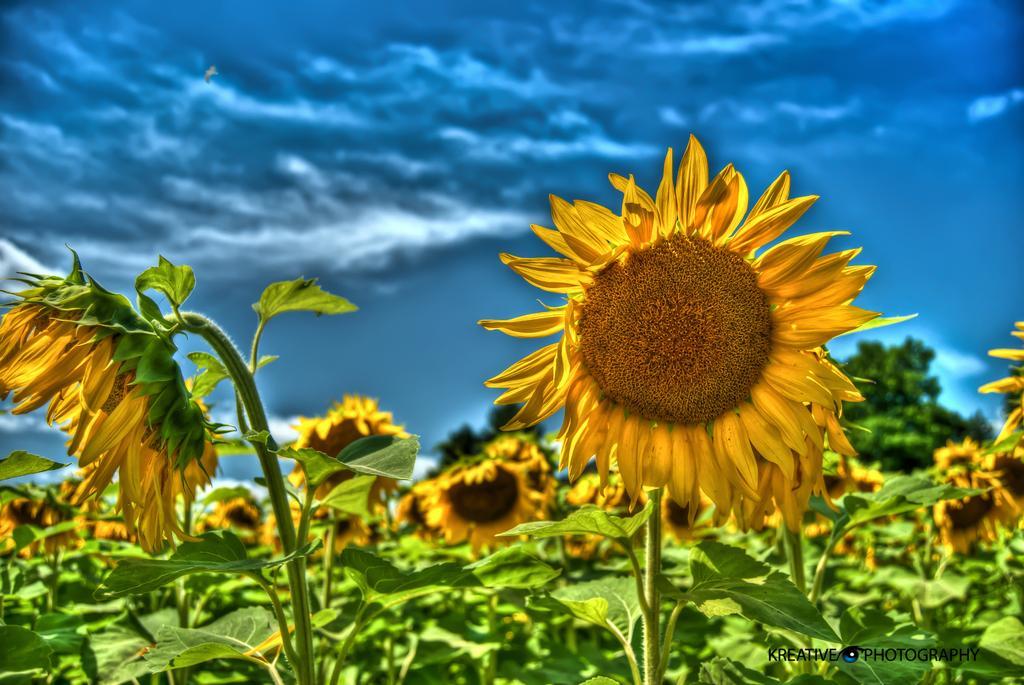Describe this image in one or two sentences. In this image, we can see some plants. There is a sky at the top of the image. 